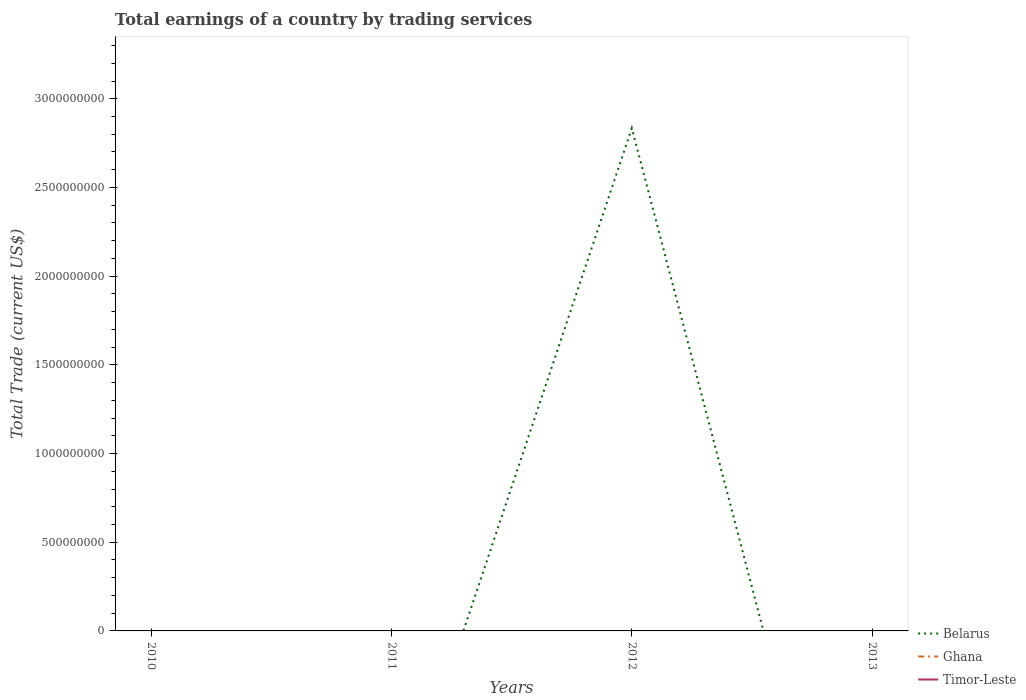Does the line corresponding to Belarus intersect with the line corresponding to Ghana?
Keep it short and to the point. Yes. What is the difference between the highest and the second highest total earnings in Belarus?
Offer a very short reply. 2.83e+09. How many years are there in the graph?
Ensure brevity in your answer.  4. Where does the legend appear in the graph?
Provide a succinct answer. Bottom right. How are the legend labels stacked?
Your response must be concise. Vertical. What is the title of the graph?
Make the answer very short. Total earnings of a country by trading services. Does "Latin America(all income levels)" appear as one of the legend labels in the graph?
Your answer should be very brief. No. What is the label or title of the X-axis?
Provide a succinct answer. Years. What is the label or title of the Y-axis?
Your response must be concise. Total Trade (current US$). What is the Total Trade (current US$) of Ghana in 2010?
Offer a very short reply. 0. What is the Total Trade (current US$) in Belarus in 2011?
Offer a very short reply. 0. What is the Total Trade (current US$) in Ghana in 2011?
Provide a short and direct response. 0. What is the Total Trade (current US$) of Timor-Leste in 2011?
Offer a terse response. 0. What is the Total Trade (current US$) of Belarus in 2012?
Your answer should be compact. 2.83e+09. What is the Total Trade (current US$) of Belarus in 2013?
Give a very brief answer. 0. What is the Total Trade (current US$) of Timor-Leste in 2013?
Give a very brief answer. 0. Across all years, what is the maximum Total Trade (current US$) in Belarus?
Make the answer very short. 2.83e+09. Across all years, what is the minimum Total Trade (current US$) of Belarus?
Offer a very short reply. 0. What is the total Total Trade (current US$) of Belarus in the graph?
Ensure brevity in your answer.  2.83e+09. What is the total Total Trade (current US$) in Ghana in the graph?
Keep it short and to the point. 0. What is the average Total Trade (current US$) of Belarus per year?
Ensure brevity in your answer.  7.08e+08. What is the difference between the highest and the lowest Total Trade (current US$) of Belarus?
Make the answer very short. 2.83e+09. 